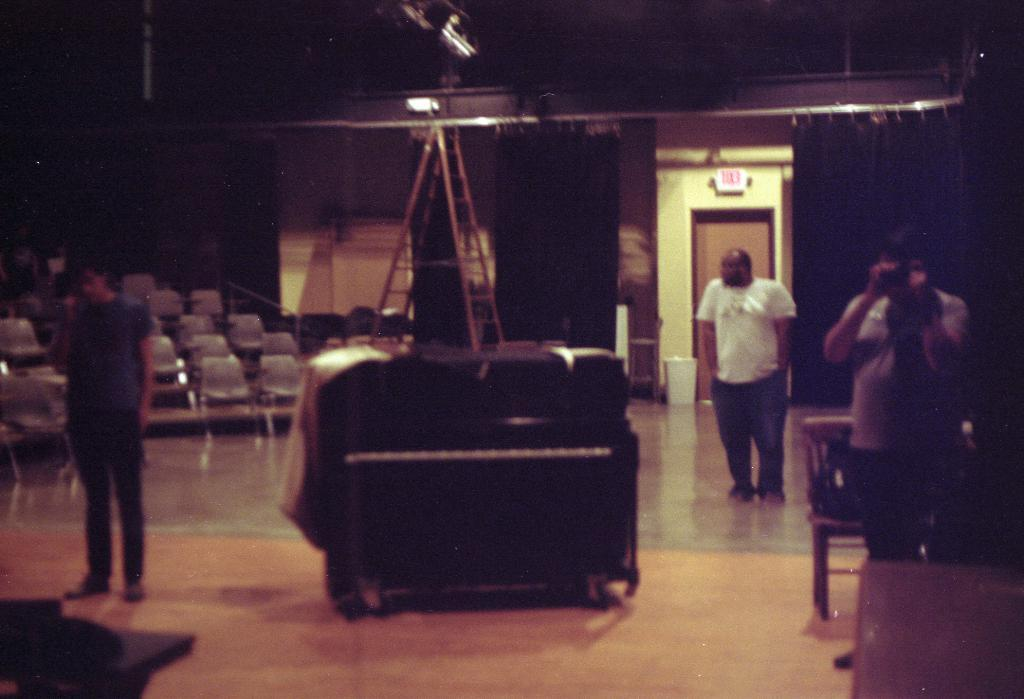What are the people in the image doing? There are persons standing on the floor in the image. Can you describe what one of the persons is holding? One of the persons is holding a camera. What can be seen in the background of the image? Chairs, railings, ladders, and a bin are visible in the background of the image. Reasoning: Let' Let's think step by step in order to produce the conversation. We start by identifying the main subjects in the image, which are the persons standing on the floor. Then, we describe what one of the persons is holding, which is a camera. Finally, we expand the conversation to include other objects visible in the background, such as chairs, railings, ladders, and a bin. Each question is designed to elicit a specific detail about the image that is known from the provided facts. Absurd Question/Answer: What type of rose can be seen growing on the floor in the image? There is no rose present in the image; the floor is occupied by the persons standing in the image. 